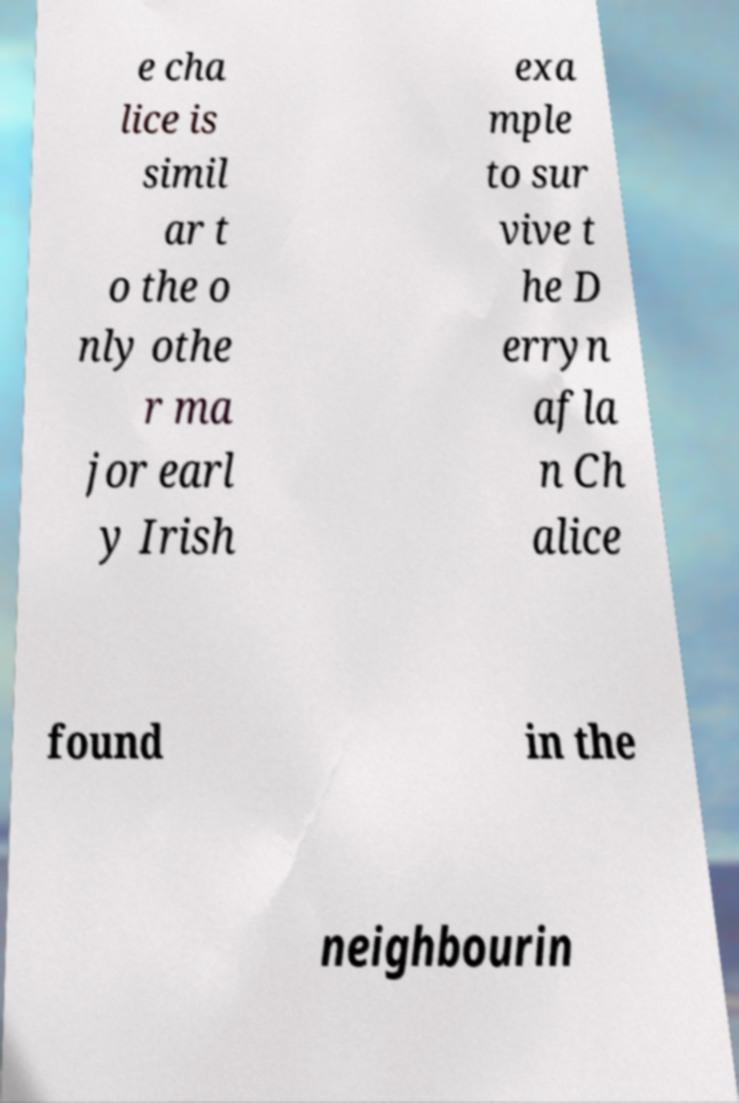What messages or text are displayed in this image? I need them in a readable, typed format. e cha lice is simil ar t o the o nly othe r ma jor earl y Irish exa mple to sur vive t he D erryn afla n Ch alice found in the neighbourin 